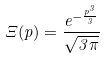Convert formula to latex. <formula><loc_0><loc_0><loc_500><loc_500>\Xi ( p ) = \frac { e ^ { - \frac { p ^ { 3 } } { 3 } } } { \sqrt { 3 \pi } }</formula> 